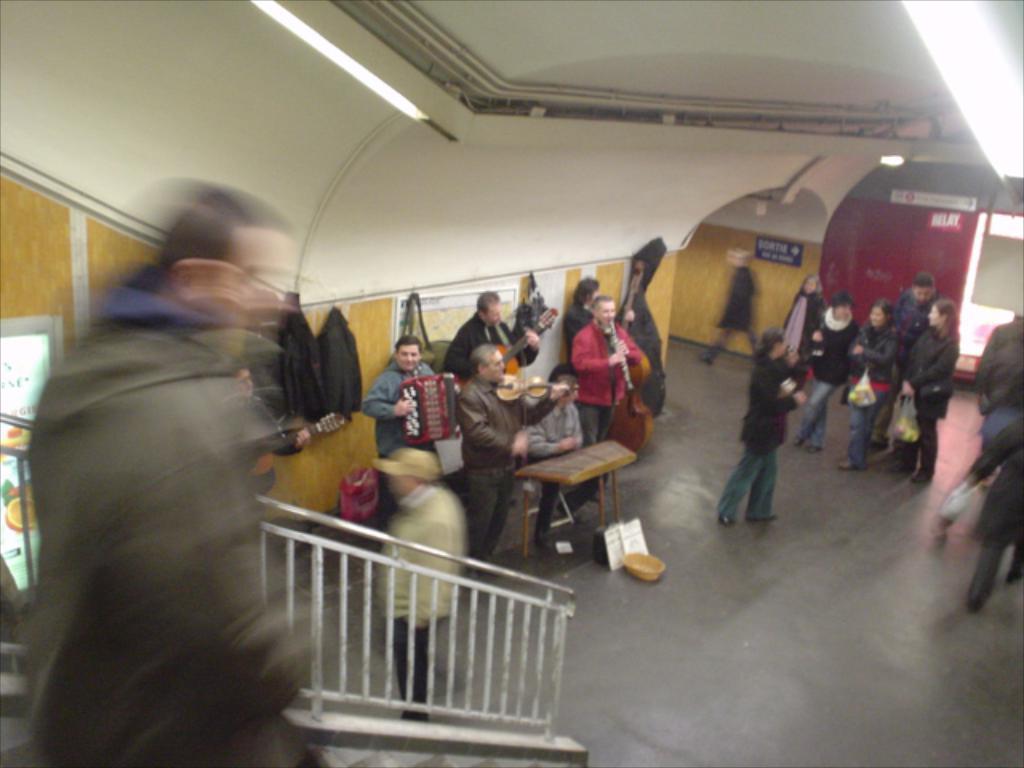Please provide a concise description of this image. In this image we can see this person getting down the stairs is blurred. Here we can see these people are playing musical instruments, we can see these people walking on the floor, we can see boards and the lights to the ceiling. 